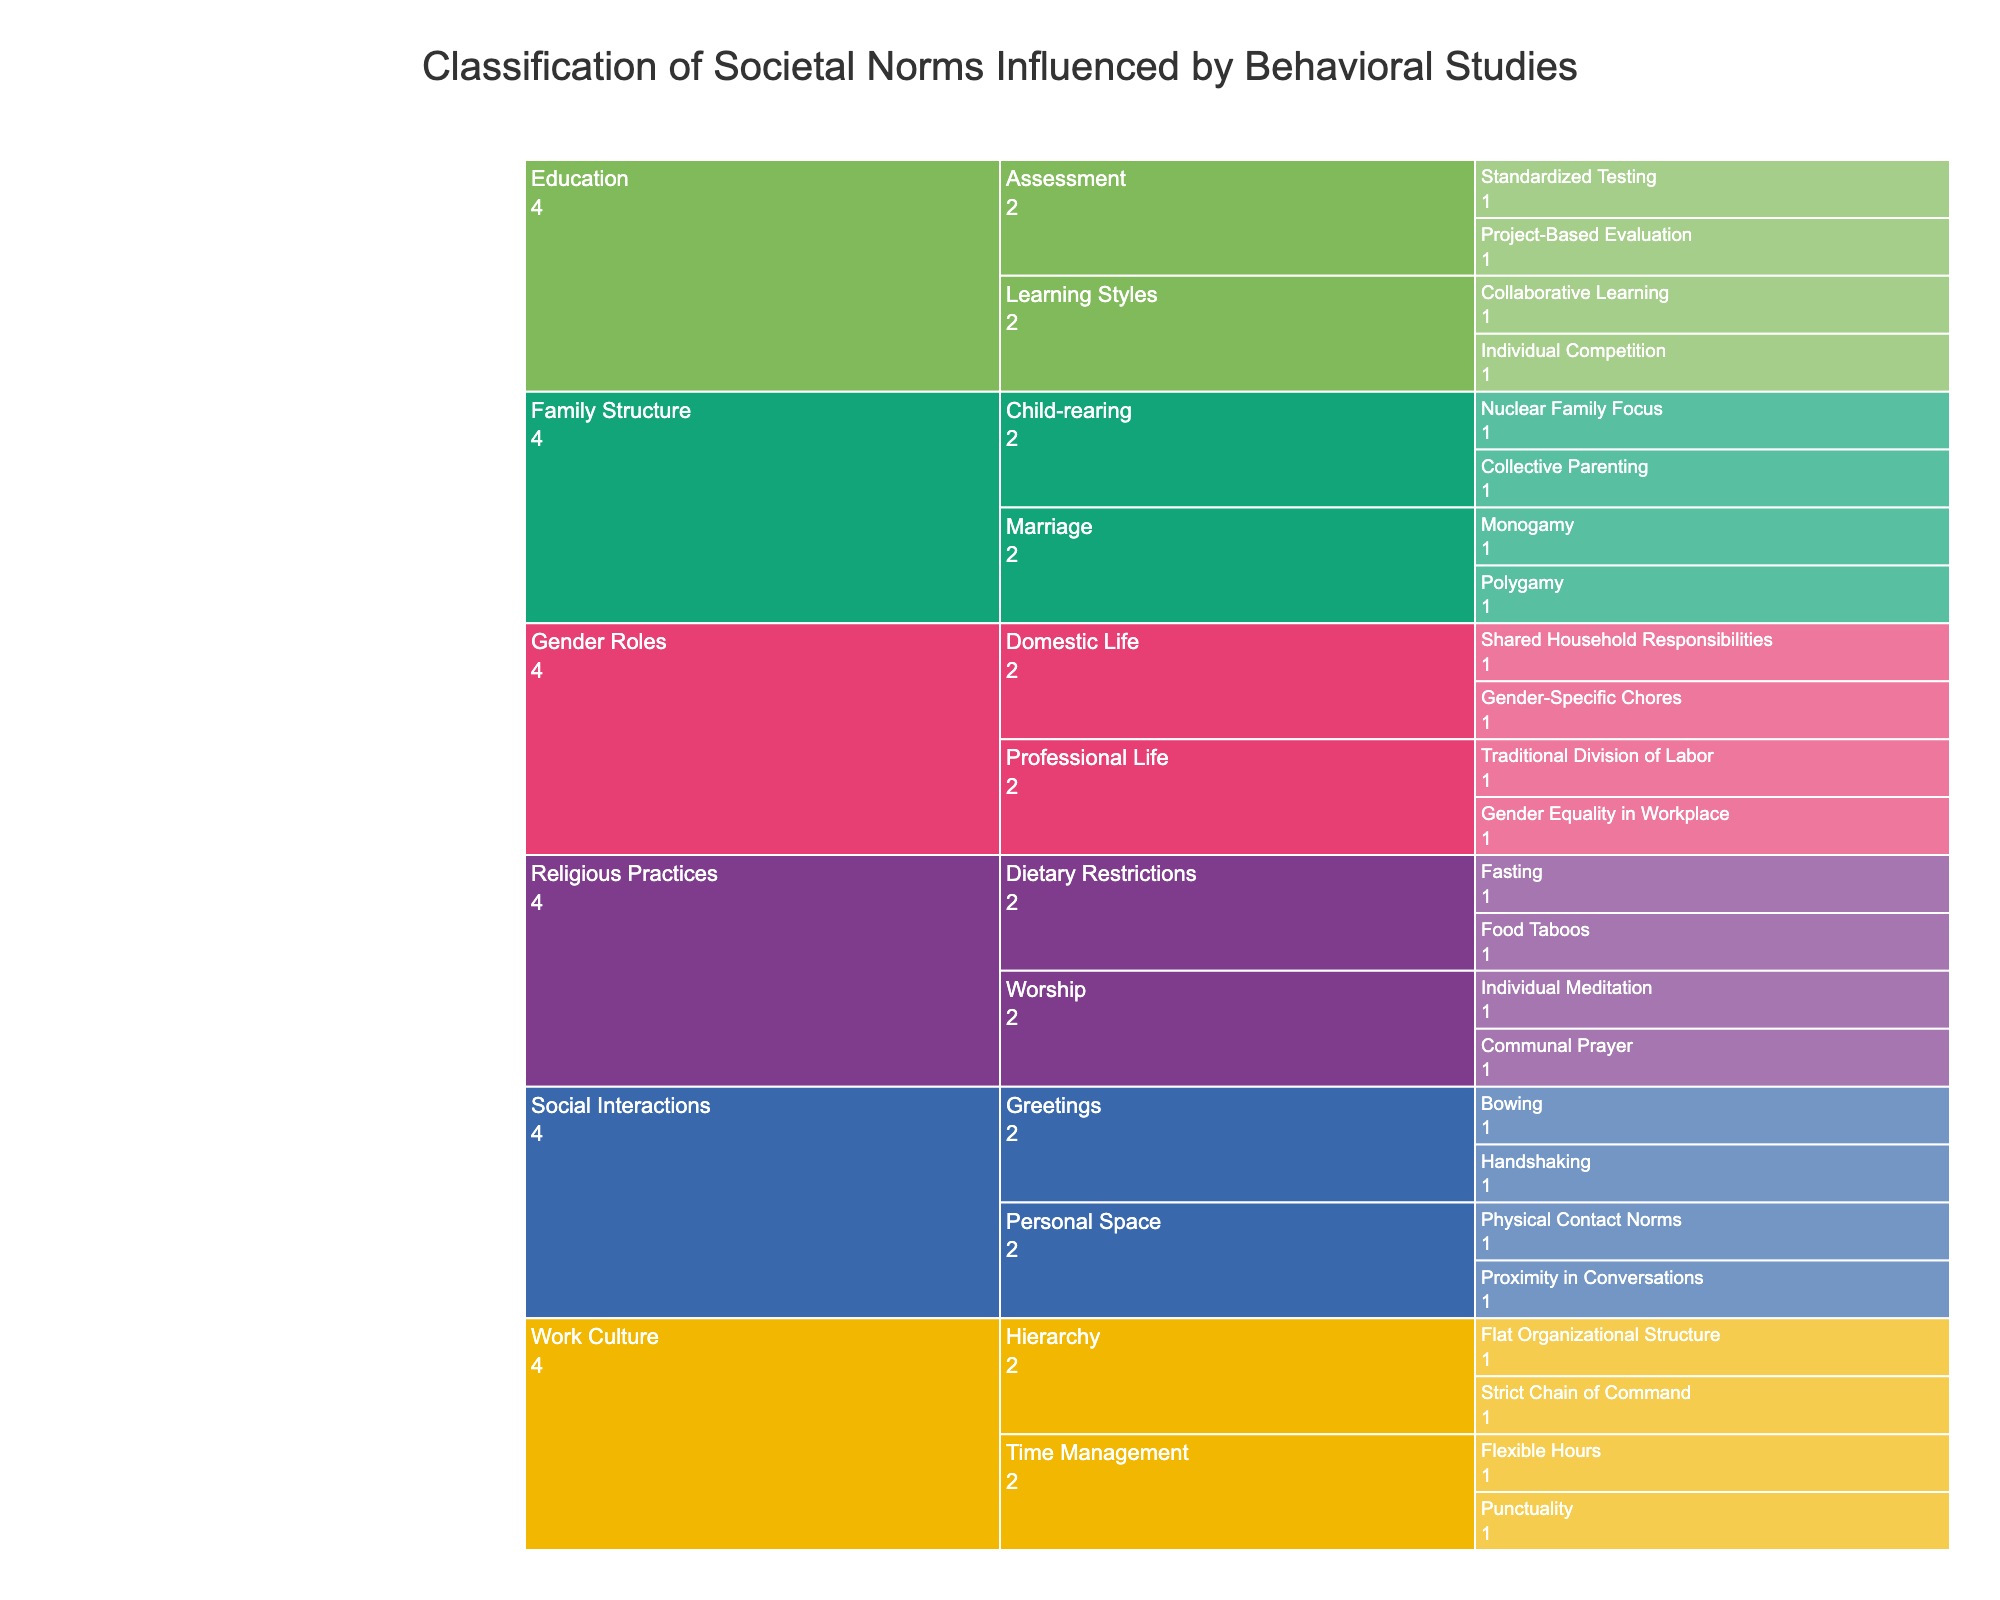what is the title of the icicle chart? The title of the icicle chart is usually displayed at the top of the figure. Here, the title is "Classification of Societal Norms Influenced by Behavioral Studies".
Answer: Classification of Societal Norms Influenced by Behavioral Studies How many Norm Categories are there under the "Family Structure" Cultural Domain? To determine the number of Norm Categories under "Family Structure", we look at the branches stemming from it. The categories are "Marriage" and "Child-rearing".
Answer: 2 What are the specific norms under the "Time Management" category in "Work Culture"? We look under the "Work Culture" domain, and find the "Time Management" category. Under this, the specific norms are "Punctuality" and "Flexible Hours".
Answer: Punctuality, Flexible Hours Which Cultural Domain contains norms related to "Dietary Restrictions"? Identify the Cultural Domain where "Dietary Restrictions" appears. It is found under the "Religious Practices" domain.
Answer: Religious Practices Which Cultural Domain has the most Norm Categories? Count the Norm Categories under each Cultural Domain. "Work Culture" has the most categories, which are "Time Management" and "Hierarchy".
Answer: Work Culture Are there more Norm Categories under "Education" or "Gender Roles"? Count the Norm Categories under both "Education" and "Gender Roles". "Education" consists of "Learning Styles" and "Assessment" (2 categories), whereas "Gender Roles" includes "Professional Life" and "Domestic Life" (2 categories). They have equal numbers.
Answer: Equal Which category within "Gender Roles" mentions "Gender Equality in Workplace"? Locate the "Gender Roles" domain and observe the categories to find where "Gender Equality in Workplace" is listed. It appears under "Professional Life".
Answer: Professional Life How many specific norms deal with "Personal Space" under "Social Interactions"? Identify the "Personal Space" category under the "Social Interactions" domain and count its specific norms, which are "Proximity in Conversations" and "Physical Contact Norms".
Answer: 2 Are there any domains that have norms about both "Individual" and "Communal" behaviors? Check for specific norms that explicitly mention "Individual" and "Communal" within different categories. "Religious Practices" covers both with "Individual Meditation" and "Communal Prayer".
Answer: Religious Practices What is the relationship between "Collaborative Learning" and "Individual Competition"? Identify the Cultural Domain and Norm Category for these norms. Both "Collaborative Learning" and "Individual Competition" belong to the "Learning Styles" category under "Education".
Answer: Both relate to Education, specifically Learning Styles 